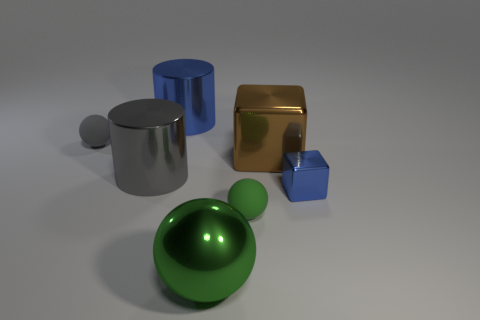There is a thing that is left of the green rubber thing and in front of the small metal cube; what is it made of?
Give a very brief answer. Metal. What number of shiny things are both in front of the small blue block and to the left of the large ball?
Provide a succinct answer. 0. What material is the gray sphere?
Offer a terse response. Rubber. Are there an equal number of small gray things in front of the tiny blue cube and big brown cubes?
Offer a terse response. No. What number of green shiny objects have the same shape as the small blue metallic object?
Offer a terse response. 0. Does the green matte object have the same shape as the gray matte thing?
Keep it short and to the point. Yes. How many things are large cylinders that are behind the tiny gray matte object or big brown metal things?
Your response must be concise. 2. What is the shape of the matte object that is behind the small green rubber ball that is on the left side of the blue object to the right of the large green ball?
Offer a very short reply. Sphere. There is a green object that is made of the same material as the blue cylinder; what shape is it?
Ensure brevity in your answer.  Sphere. What is the size of the green matte thing?
Keep it short and to the point. Small. 